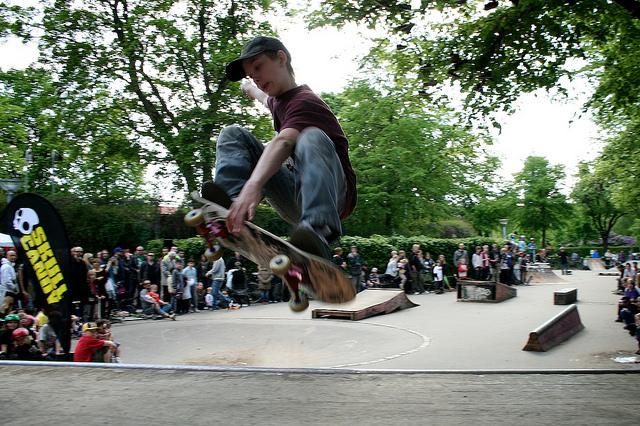Are there a lot of people watching this person skateboard?
Be succinct. Yes. Do you see any trees?
Concise answer only. Yes. What is the name of this skate park?
Answer briefly. Skullcandy. 